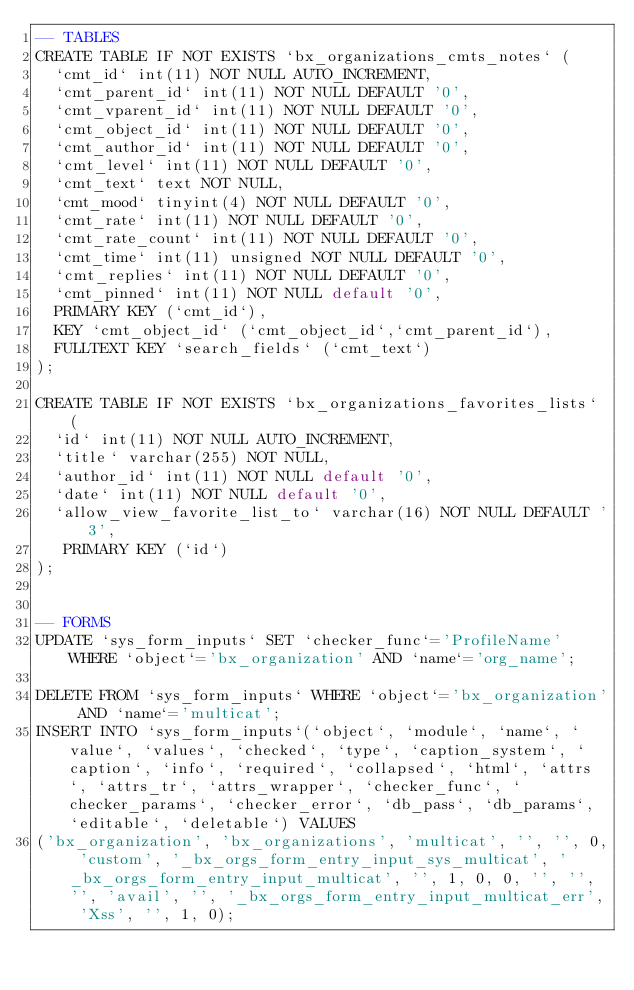Convert code to text. <code><loc_0><loc_0><loc_500><loc_500><_SQL_>-- TABLES
CREATE TABLE IF NOT EXISTS `bx_organizations_cmts_notes` (
  `cmt_id` int(11) NOT NULL AUTO_INCREMENT,
  `cmt_parent_id` int(11) NOT NULL DEFAULT '0',
  `cmt_vparent_id` int(11) NOT NULL DEFAULT '0',
  `cmt_object_id` int(11) NOT NULL DEFAULT '0',
  `cmt_author_id` int(11) NOT NULL DEFAULT '0',
  `cmt_level` int(11) NOT NULL DEFAULT '0',
  `cmt_text` text NOT NULL,
  `cmt_mood` tinyint(4) NOT NULL DEFAULT '0',
  `cmt_rate` int(11) NOT NULL DEFAULT '0',
  `cmt_rate_count` int(11) NOT NULL DEFAULT '0',
  `cmt_time` int(11) unsigned NOT NULL DEFAULT '0',
  `cmt_replies` int(11) NOT NULL DEFAULT '0',
  `cmt_pinned` int(11) NOT NULL default '0',
  PRIMARY KEY (`cmt_id`),
  KEY `cmt_object_id` (`cmt_object_id`,`cmt_parent_id`),
  FULLTEXT KEY `search_fields` (`cmt_text`)
);

CREATE TABLE IF NOT EXISTS `bx_organizations_favorites_lists` (
  `id` int(11) NOT NULL AUTO_INCREMENT,
  `title` varchar(255) NOT NULL,
  `author_id` int(11) NOT NULL default '0',
  `date` int(11) NOT NULL default '0',
  `allow_view_favorite_list_to` varchar(16) NOT NULL DEFAULT '3',
   PRIMARY KEY (`id`)
);


-- FORMS
UPDATE `sys_form_inputs` SET `checker_func`='ProfileName' WHERE `object`='bx_organization' AND `name`='org_name';

DELETE FROM `sys_form_inputs` WHERE `object`='bx_organization' AND `name`='multicat';
INSERT INTO `sys_form_inputs`(`object`, `module`, `name`, `value`, `values`, `checked`, `type`, `caption_system`, `caption`, `info`, `required`, `collapsed`, `html`, `attrs`, `attrs_tr`, `attrs_wrapper`, `checker_func`, `checker_params`, `checker_error`, `db_pass`, `db_params`, `editable`, `deletable`) VALUES 
('bx_organization', 'bx_organizations', 'multicat', '', '', 0, 'custom', '_bx_orgs_form_entry_input_sys_multicat', '_bx_orgs_form_entry_input_multicat', '', 1, 0, 0, '', '', '', 'avail', '', '_bx_orgs_form_entry_input_multicat_err', 'Xss', '', 1, 0);

</code> 